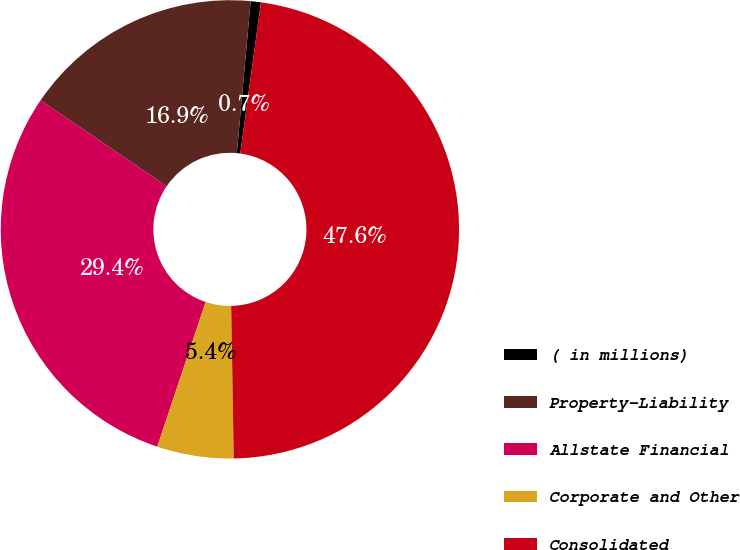Convert chart. <chart><loc_0><loc_0><loc_500><loc_500><pie_chart><fcel>( in millions)<fcel>Property-Liability<fcel>Allstate Financial<fcel>Corporate and Other<fcel>Consolidated<nl><fcel>0.72%<fcel>16.92%<fcel>29.39%<fcel>5.4%<fcel>47.57%<nl></chart> 